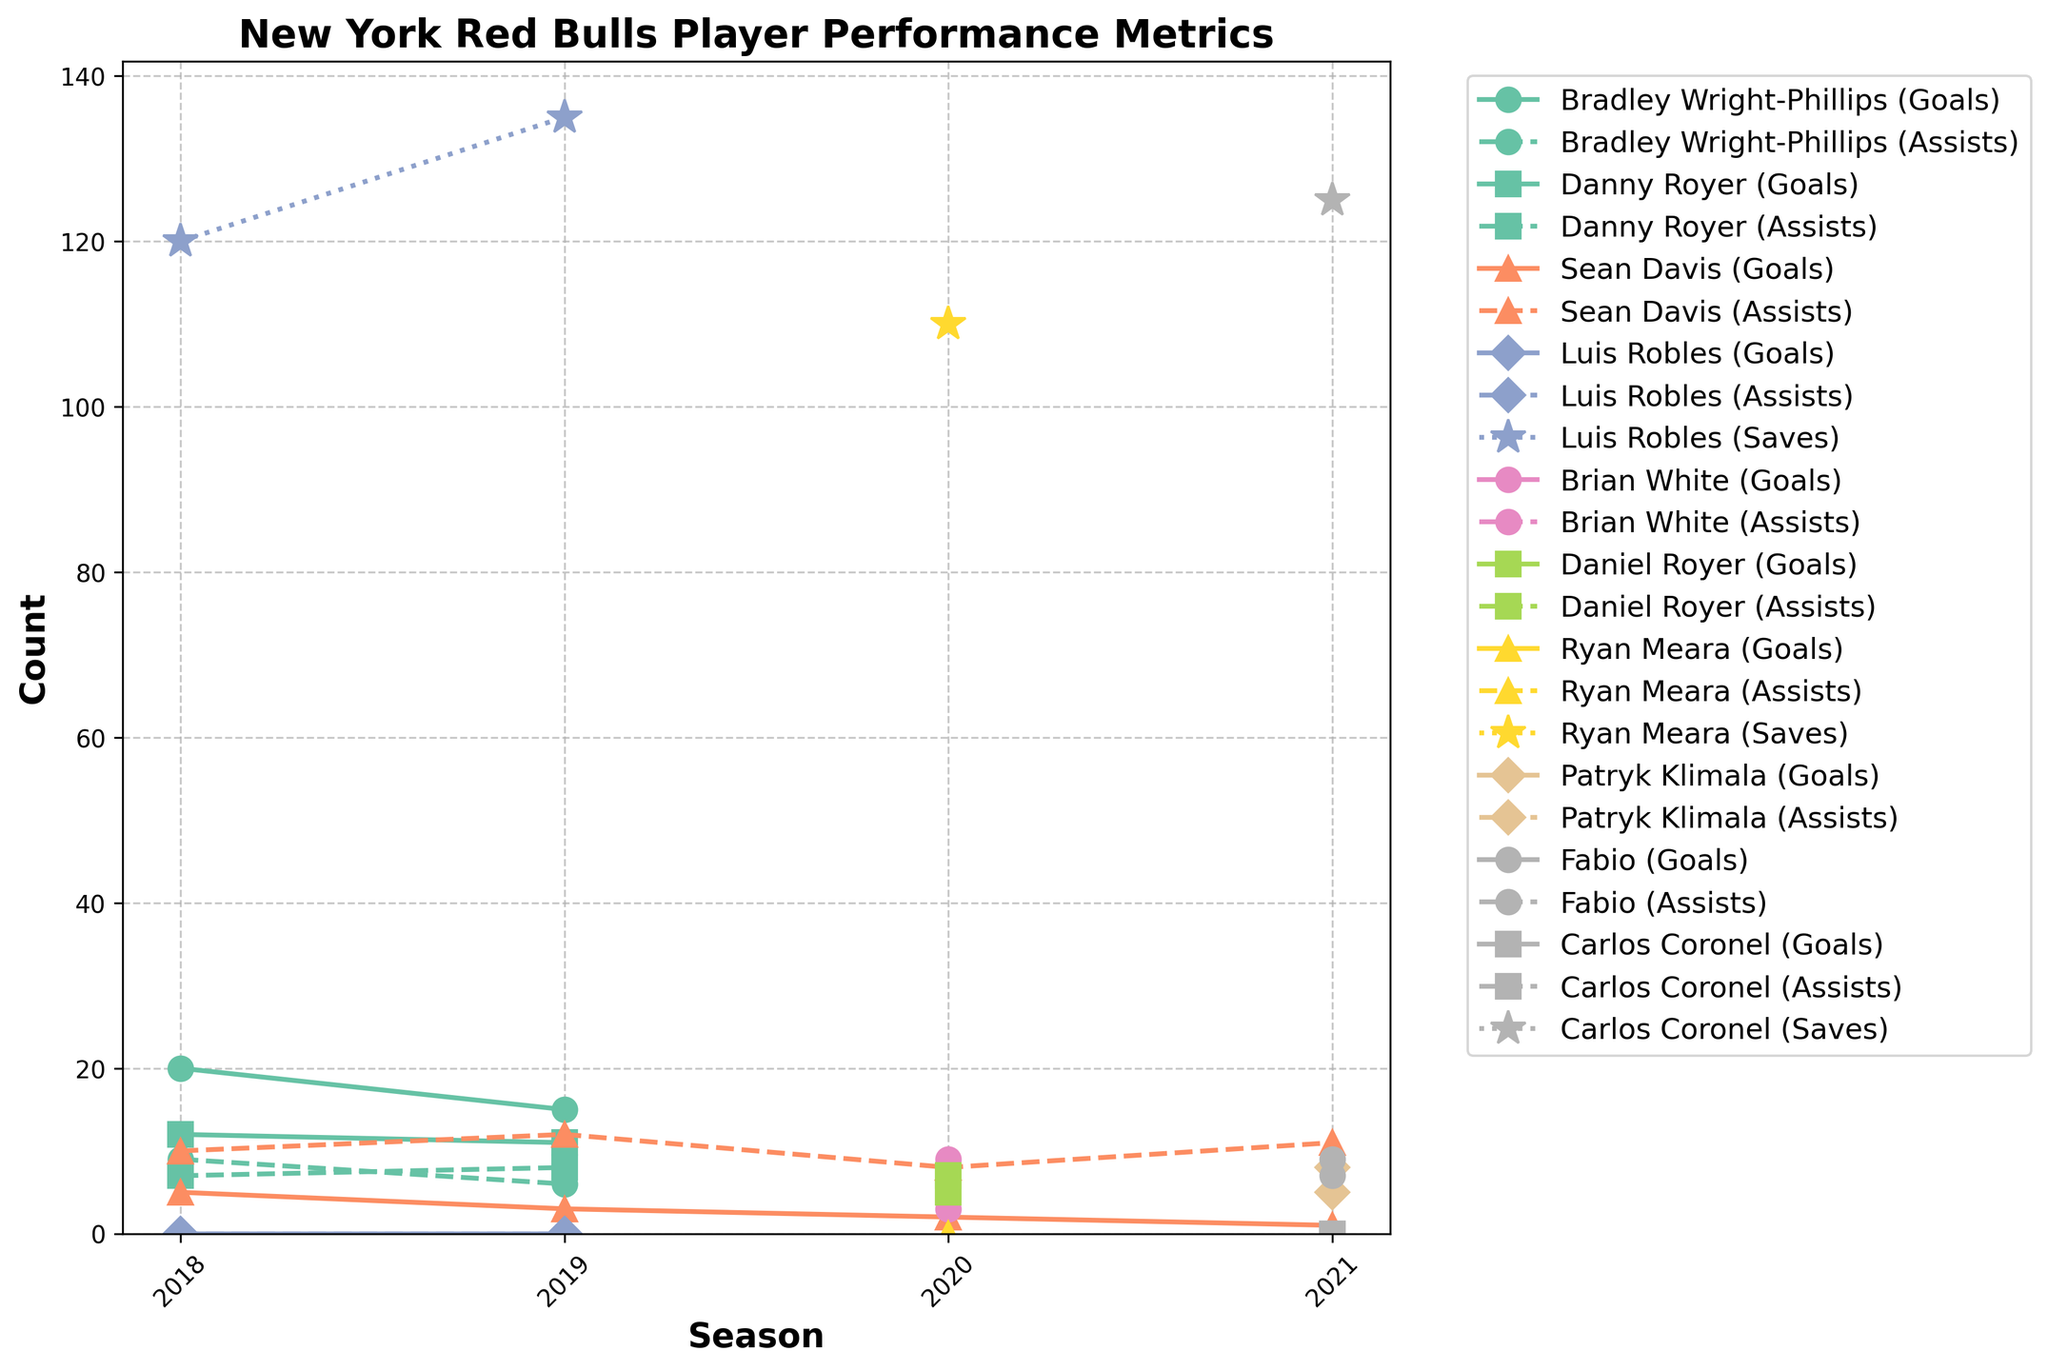What is the title of the figure? The title is displayed at the top of the figure, indicating what the figure is about. In our case, the title is "New York Red Bulls Player Performance Metrics."
Answer: New York Red Bulls Player Performance Metrics What metrics are being tracked for the players in the figure? The figure contains lines labeled with different metrics for players which include Goals, Assists, and Saves.
Answer: Goals, Assists, Saves Which player had the highest number of goals in 2018? By looking at the lines for each player in 2018, Bradley Wright-Phillips has the line with the highest "Goals" data point.
Answer: Bradley Wright-Phillips How did Luis Robles's saves change from 2018 to 2019? By tracing the line for Luis Robles between 2018 and 2019, we see an increase from 120 saves to 135 saves.
Answer: Increased Which player had the highest number of assists in 2021? The player's assist line with the highest data point for 2021 is for Sean Davis with 11 assists.
Answer: Sean Davis Compare the goals of Bradley Wright-Phillips in 2018 to 2019. Bradley Wright-Phillips' goal line shows a drop from 20 goals in 2018 to 15 goals in 2019.
Answer: Decreased What is the overall trend of Sean Davis's assists from 2018 to 2021? Sean Davis’s assists line indicates a consistent increase from 10 assists in 2018 to 11 assists in 2021.
Answer: Increased Which player had a consistent metric tracked in the figure from 2018 to 2021? Sean Davis has lines for both goals and assists consistently every year from 2018 to 2021.
Answer: Sean Davis How did Ryan Meara's saves compare to Luis Robles' saves in their respective latest seasons? Ryan Meara's saves in 2020 were 110, while Luis Robles' latest saves in 2019 were 135. Luis Robles had more saves.
Answer: Luis Robles had more saves Who had a higher number of total data points for assists over the entire period - Fabio or Felipe? Adding up all of Fabio’s assists for his single year (2021: 9 assists) and considering Felipe is not in the figure, Fabio has more assists.
Answer: Fabio 